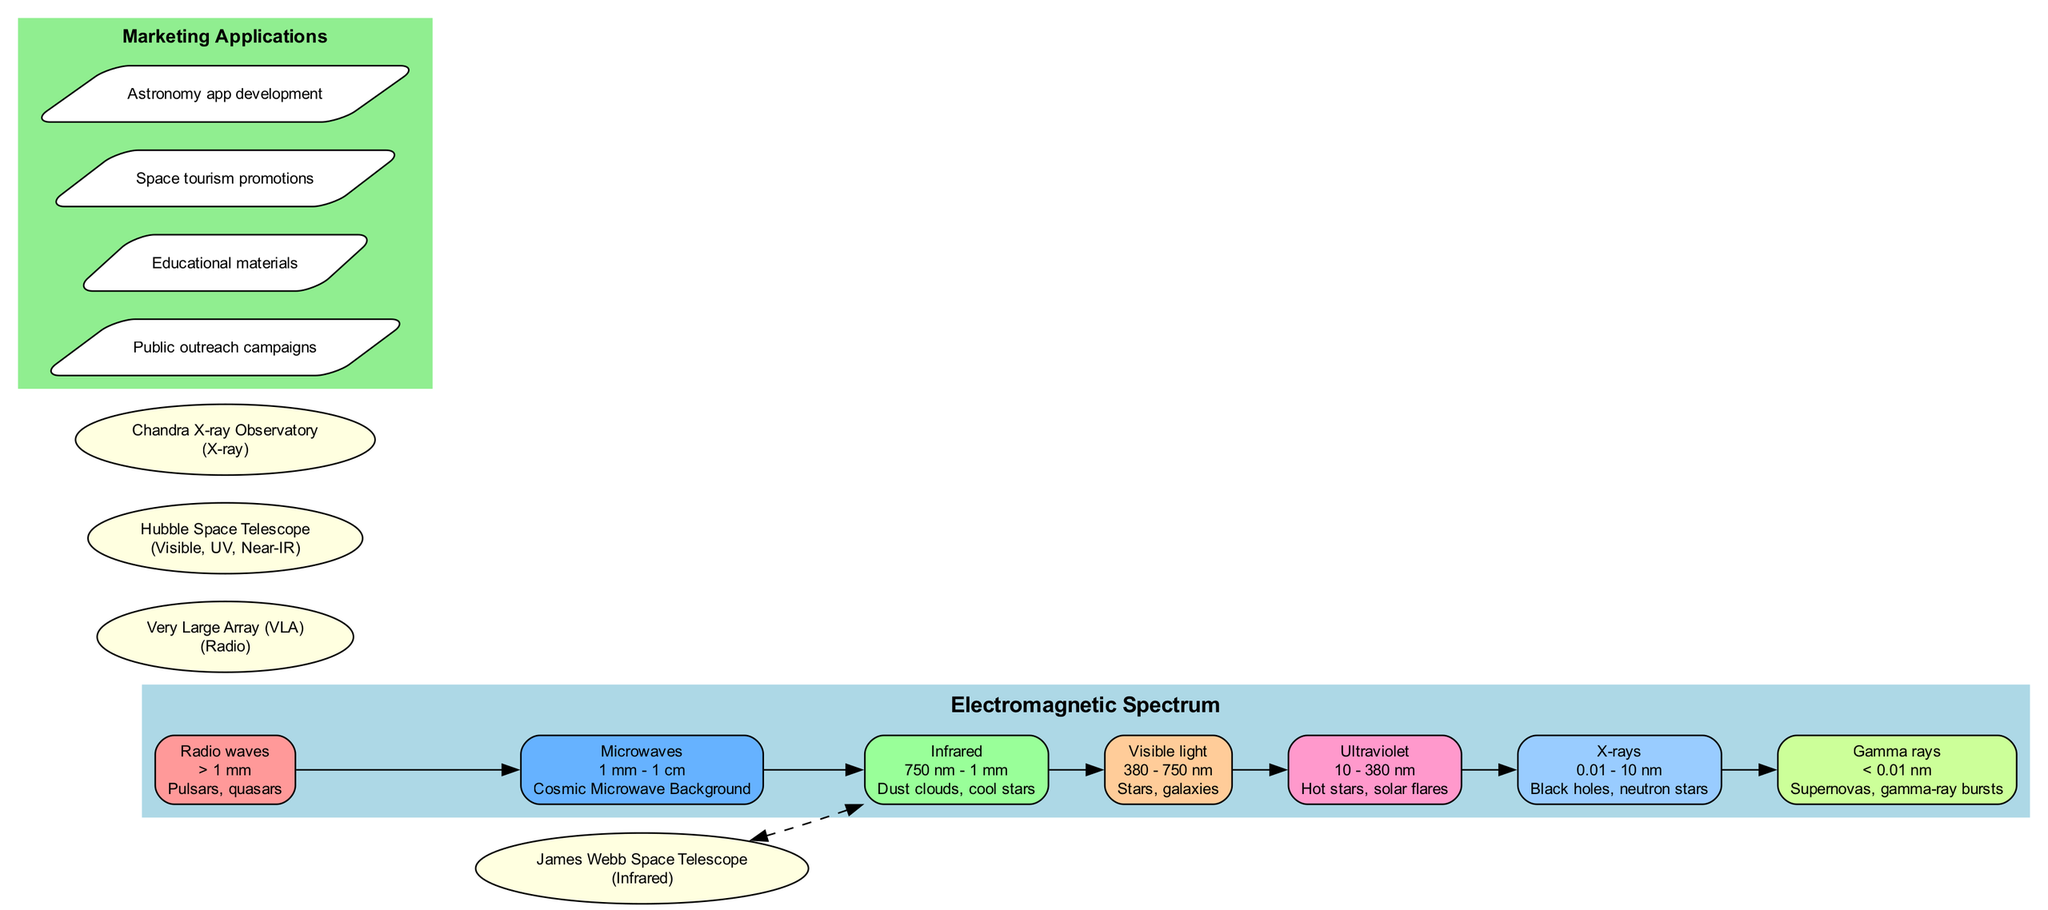What is the wavelength range for X-rays? According to the diagram, the wavelength range for X-rays is 0.01 - 10 nm. This information is specifically noted under the X-ray section in the spectrum cluster.
Answer: 0.01 - 10 nm Which telescope is associated with infrared observations? The diagram shows that the James Webb Space Telescope is the one associated with infrared observations. This is explicitly mentioned in the key telescopes section.
Answer: James Webb Space Telescope What example is provided for visible light? Under the visible light section of the spectrum, the example given is "Stars, galaxies." This detail summarizes what is commonly observed in that wavelength range.
Answer: Stars, galaxies How many types of electromagnetic waves are listed in the diagram? The diagram lists seven types of electromagnetic waves under the electromagnetic spectrum cluster. By counting each listed type from the data, we conclude the total count.
Answer: 7 Which wavelength type corresponds to quasars? The spectrum section indicates that quasars fall under the category of radio waves. This can be deduced from the examples provided for the different wavelengths.
Answer: Radio waves Name one marketing application mentioned in the diagram. The diagram lists several marketing applications, one of which is "Public outreach campaigns." This is directly referenced in the marketing applications cluster.
Answer: Public outreach campaigns Who operates the Hubble Space Telescope? The diagram specifies the Hubble Space Telescope as operating in the visible, UV, and near-infrared regions of the spectrum. This categorization helps to understand its astronomical applications.
Answer: Hubble Space Telescope What is the color assigned to the infrared category? According to the diagram, the color assigned to the infrared category is light green, which can be inferred by the fill colors given in the spectrum nodes.
Answer: Light green Which phenomenon is observed in gamma rays? The diagram states that "Supernovas, gamma-ray bursts" are examples of phenomena observed in gamma rays. This is directly detailed in the corresponding spectrum section.
Answer: Supernovas, gamma-ray bursts 